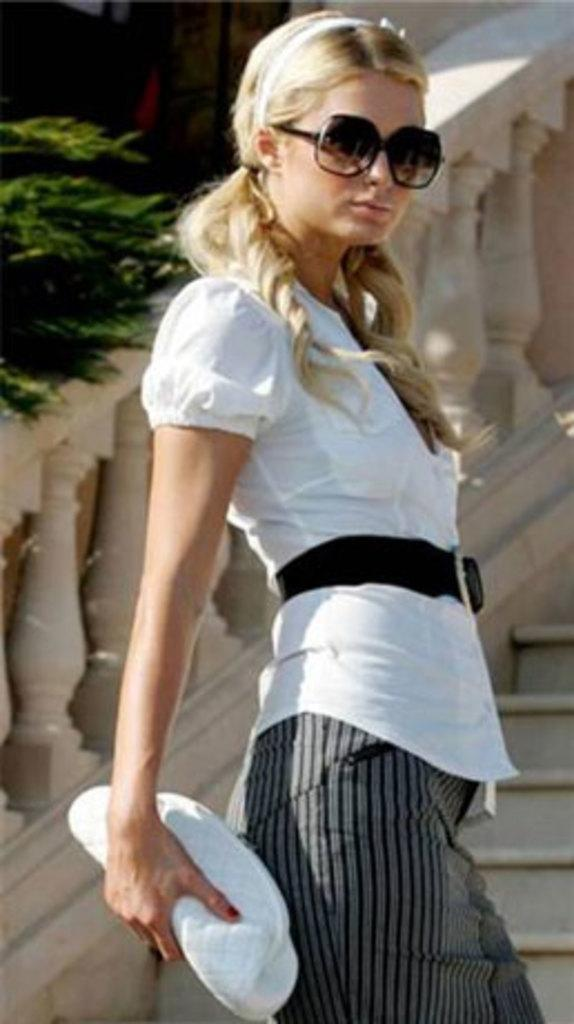Who is the main subject in the image? There is a lady in the center of the image. What is the lady doing in the image? The lady is standing. What is the lady wearing in the image? The lady is wearing a dress and goggles. What is the lady holding in the image? The lady is holding a wallet. What can be seen in the background of the image? There are stairs, a railing, and trees in the background of the image. What type of popcorn is the lady eating in the image? There is no popcorn present in the image; the lady is holding a wallet. What substance is causing the lady's throat to feel scratchy in the image? There is no indication of any throat discomfort or substance causing it in the image. 